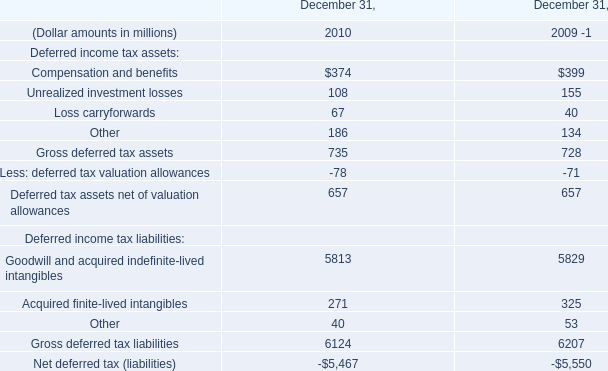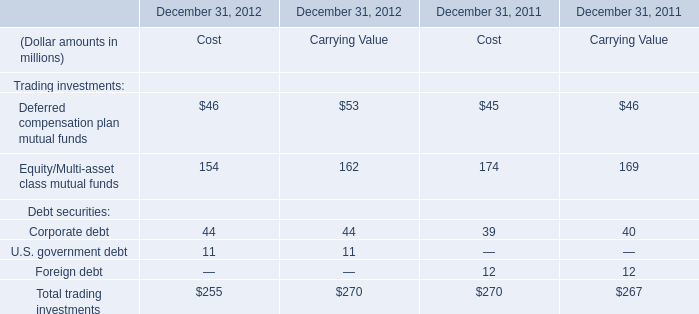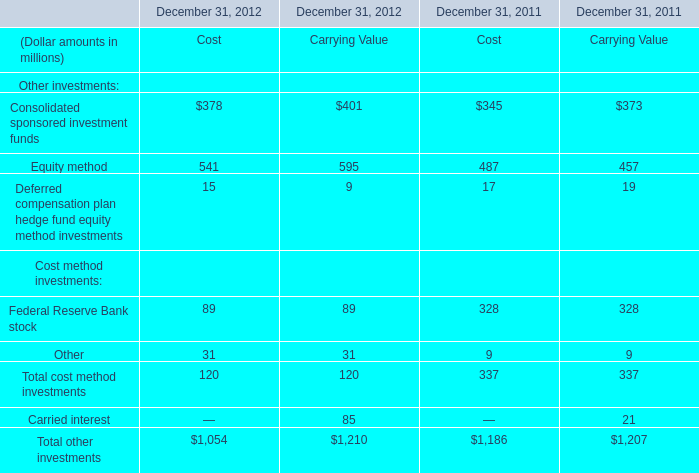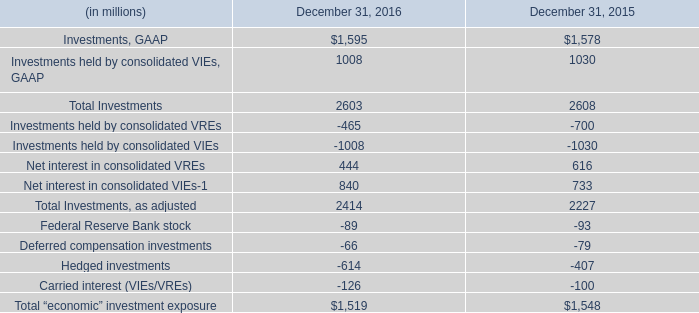What's the current increasing rate of Equity method of cost ? 
Computations: (1 + ((541 - 487) / 487))
Answer: 1.11088. 